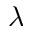<formula> <loc_0><loc_0><loc_500><loc_500>\lambda</formula> 